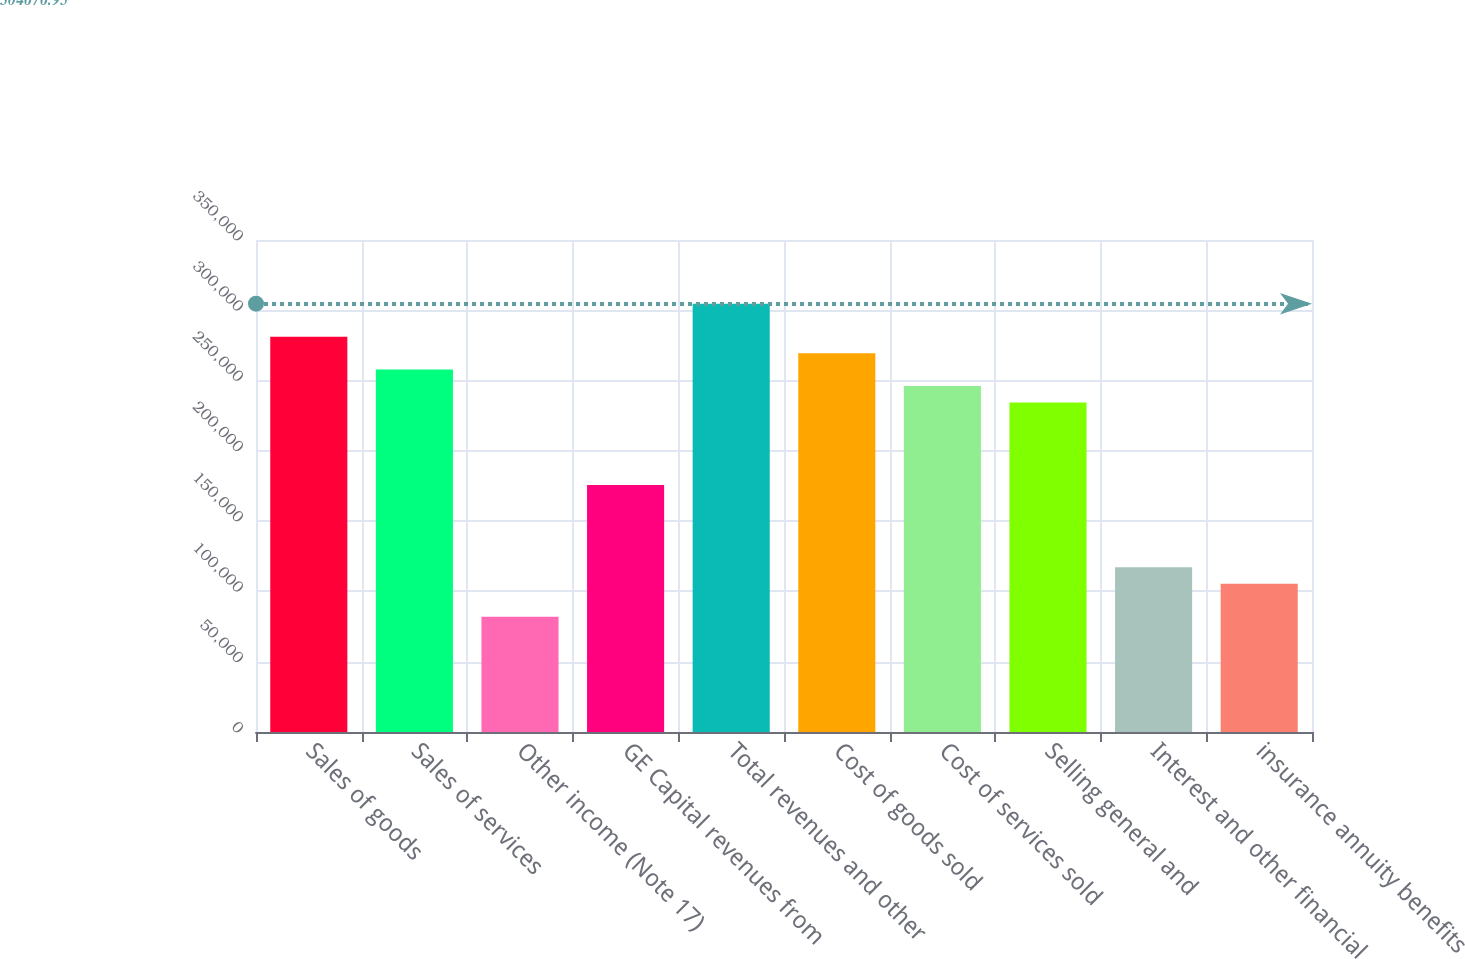Convert chart. <chart><loc_0><loc_0><loc_500><loc_500><bar_chart><fcel>Sales of goods<fcel>Sales of services<fcel>Other income (Note 17)<fcel>GE Capital revenues from<fcel>Total revenues and other<fcel>Cost of goods sold<fcel>Cost of services sold<fcel>Selling general and<fcel>Interest and other financial<fcel>insurance annuity benefits<nl><fcel>281240<fcel>257804<fcel>82029.1<fcel>175776<fcel>304677<fcel>269522<fcel>246085<fcel>234367<fcel>117184<fcel>105466<nl></chart> 